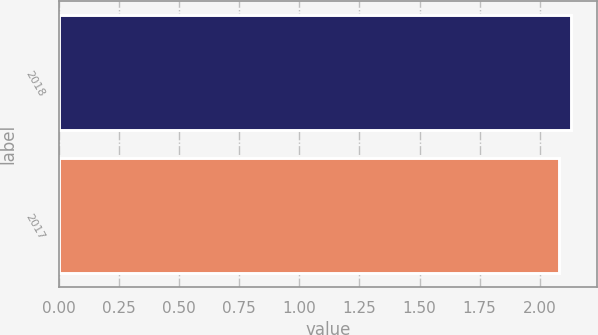Convert chart to OTSL. <chart><loc_0><loc_0><loc_500><loc_500><bar_chart><fcel>2018<fcel>2017<nl><fcel>2.13<fcel>2.08<nl></chart> 